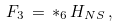<formula> <loc_0><loc_0><loc_500><loc_500>F _ { 3 } \, = \, * _ { 6 } \, H _ { N S } \, ,</formula> 